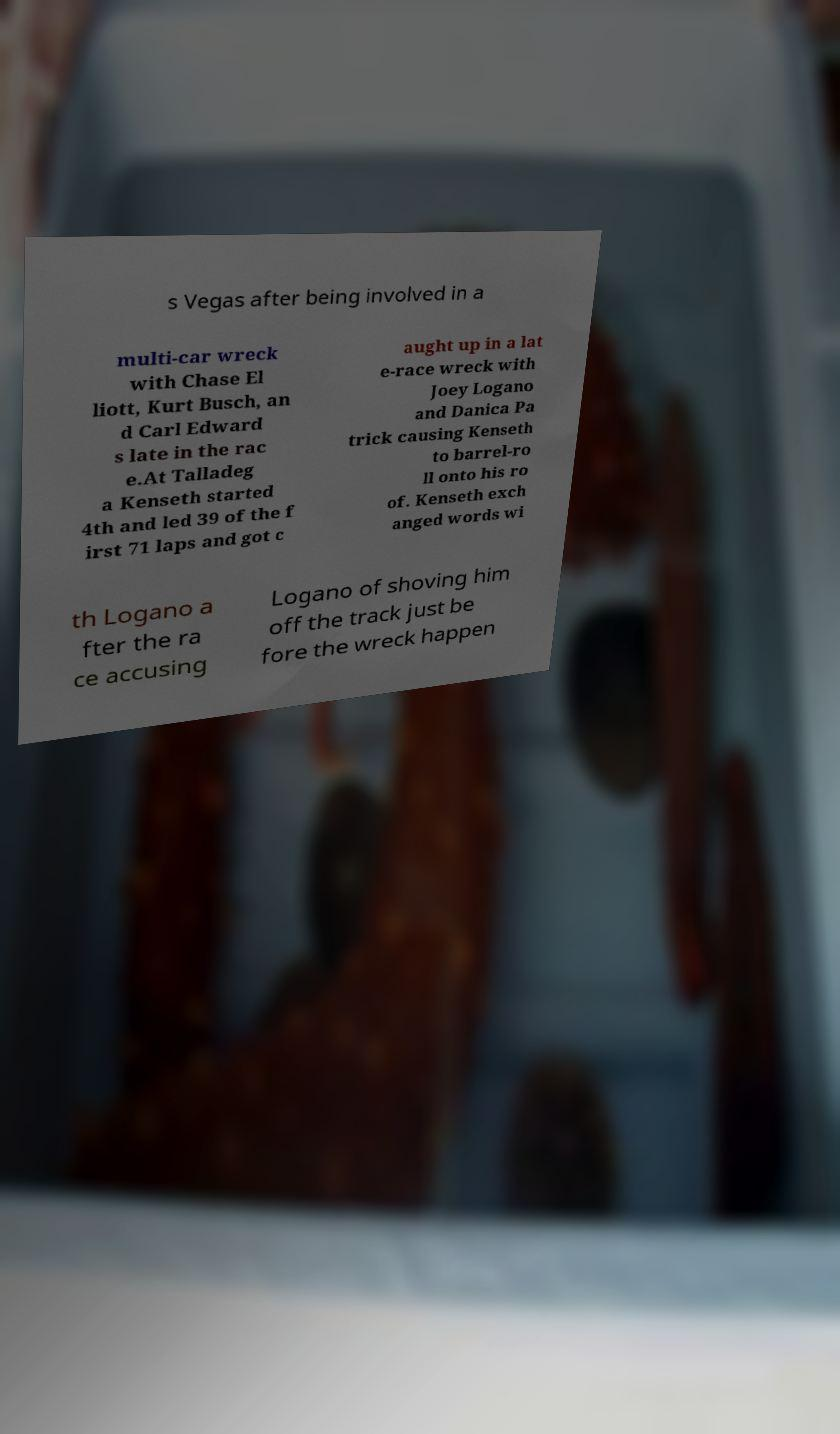Can you read and provide the text displayed in the image?This photo seems to have some interesting text. Can you extract and type it out for me? s Vegas after being involved in a multi-car wreck with Chase El liott, Kurt Busch, an d Carl Edward s late in the rac e.At Talladeg a Kenseth started 4th and led 39 of the f irst 71 laps and got c aught up in a lat e-race wreck with Joey Logano and Danica Pa trick causing Kenseth to barrel-ro ll onto his ro of. Kenseth exch anged words wi th Logano a fter the ra ce accusing Logano of shoving him off the track just be fore the wreck happen 